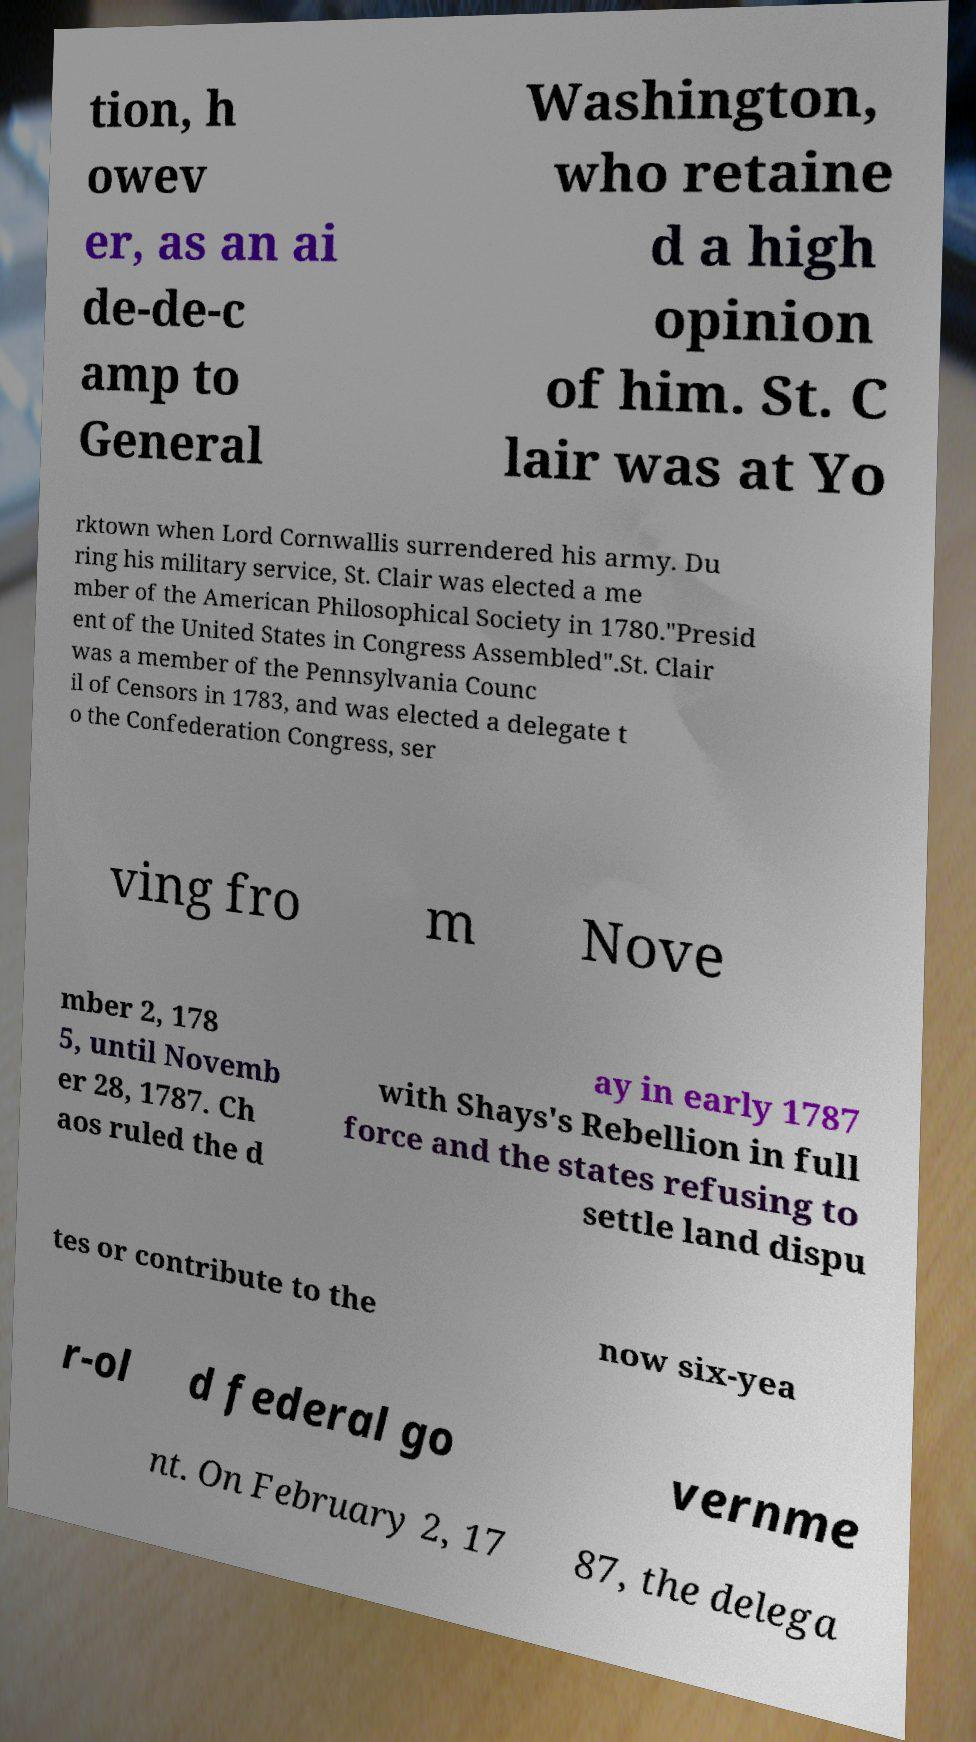I need the written content from this picture converted into text. Can you do that? tion, h owev er, as an ai de-de-c amp to General Washington, who retaine d a high opinion of him. St. C lair was at Yo rktown when Lord Cornwallis surrendered his army. Du ring his military service, St. Clair was elected a me mber of the American Philosophical Society in 1780."Presid ent of the United States in Congress Assembled".St. Clair was a member of the Pennsylvania Counc il of Censors in 1783, and was elected a delegate t o the Confederation Congress, ser ving fro m Nove mber 2, 178 5, until Novemb er 28, 1787. Ch aos ruled the d ay in early 1787 with Shays's Rebellion in full force and the states refusing to settle land dispu tes or contribute to the now six-yea r-ol d federal go vernme nt. On February 2, 17 87, the delega 